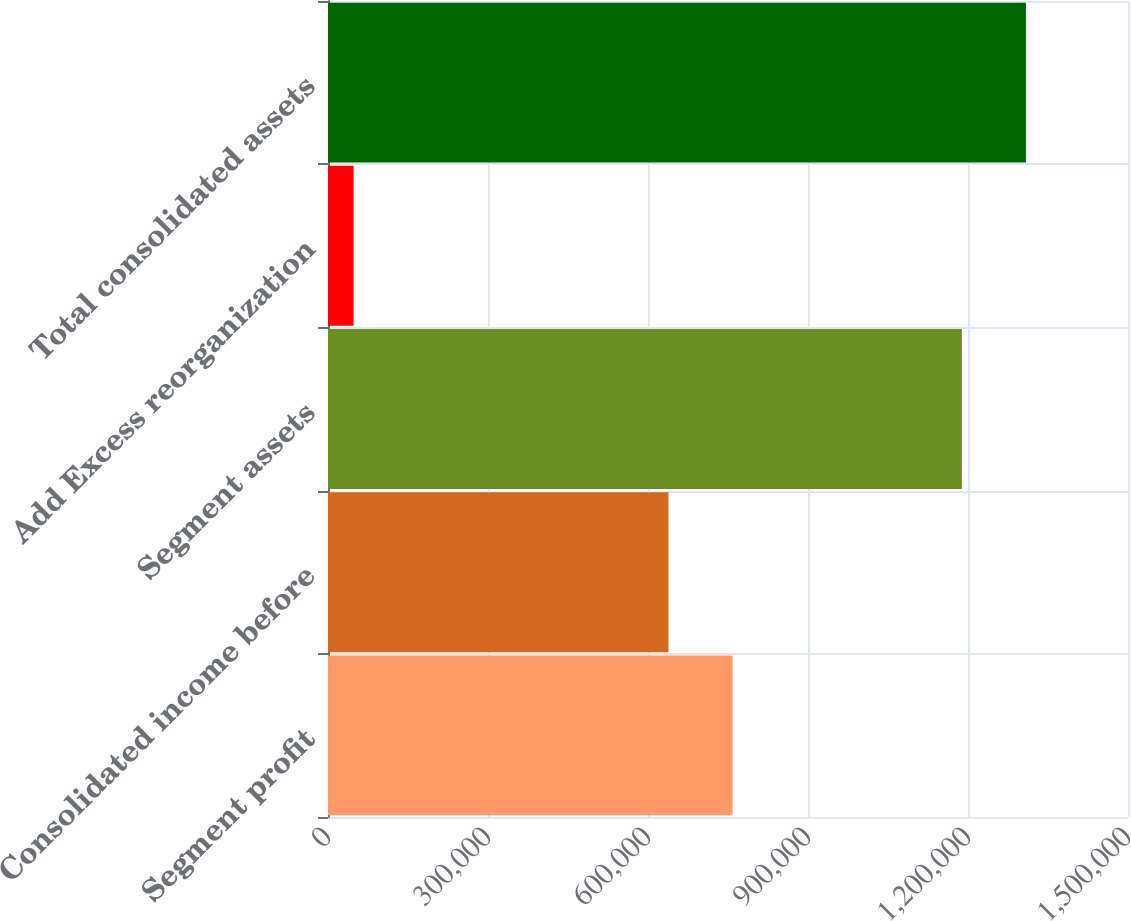Convert chart to OTSL. <chart><loc_0><loc_0><loc_500><loc_500><bar_chart><fcel>Segment profit<fcel>Consolidated income before<fcel>Segment assets<fcel>Add Excess reorganization<fcel>Total consolidated assets<nl><fcel>758544<fcel>638418<fcel>1.18845e+06<fcel>47959<fcel>1.30858e+06<nl></chart> 